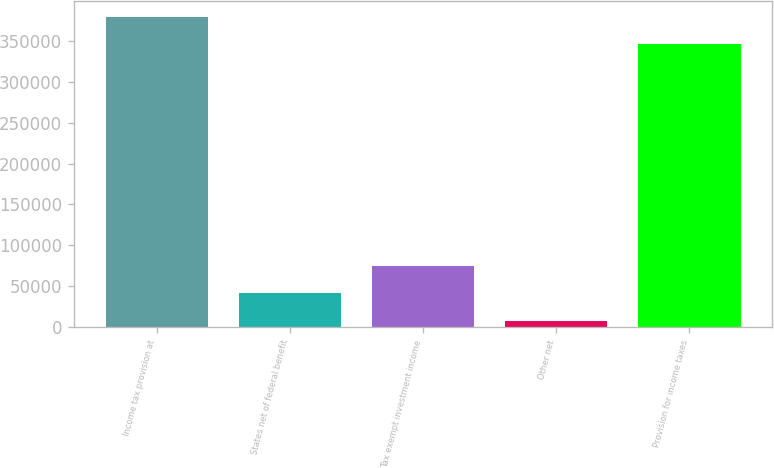Convert chart. <chart><loc_0><loc_0><loc_500><loc_500><bar_chart><fcel>Income tax provision at<fcel>States net of federal benefit<fcel>Tax exempt investment income<fcel>Other net<fcel>Provision for income taxes<nl><fcel>379740<fcel>41083.9<fcel>75129.8<fcel>7038<fcel>345694<nl></chart> 